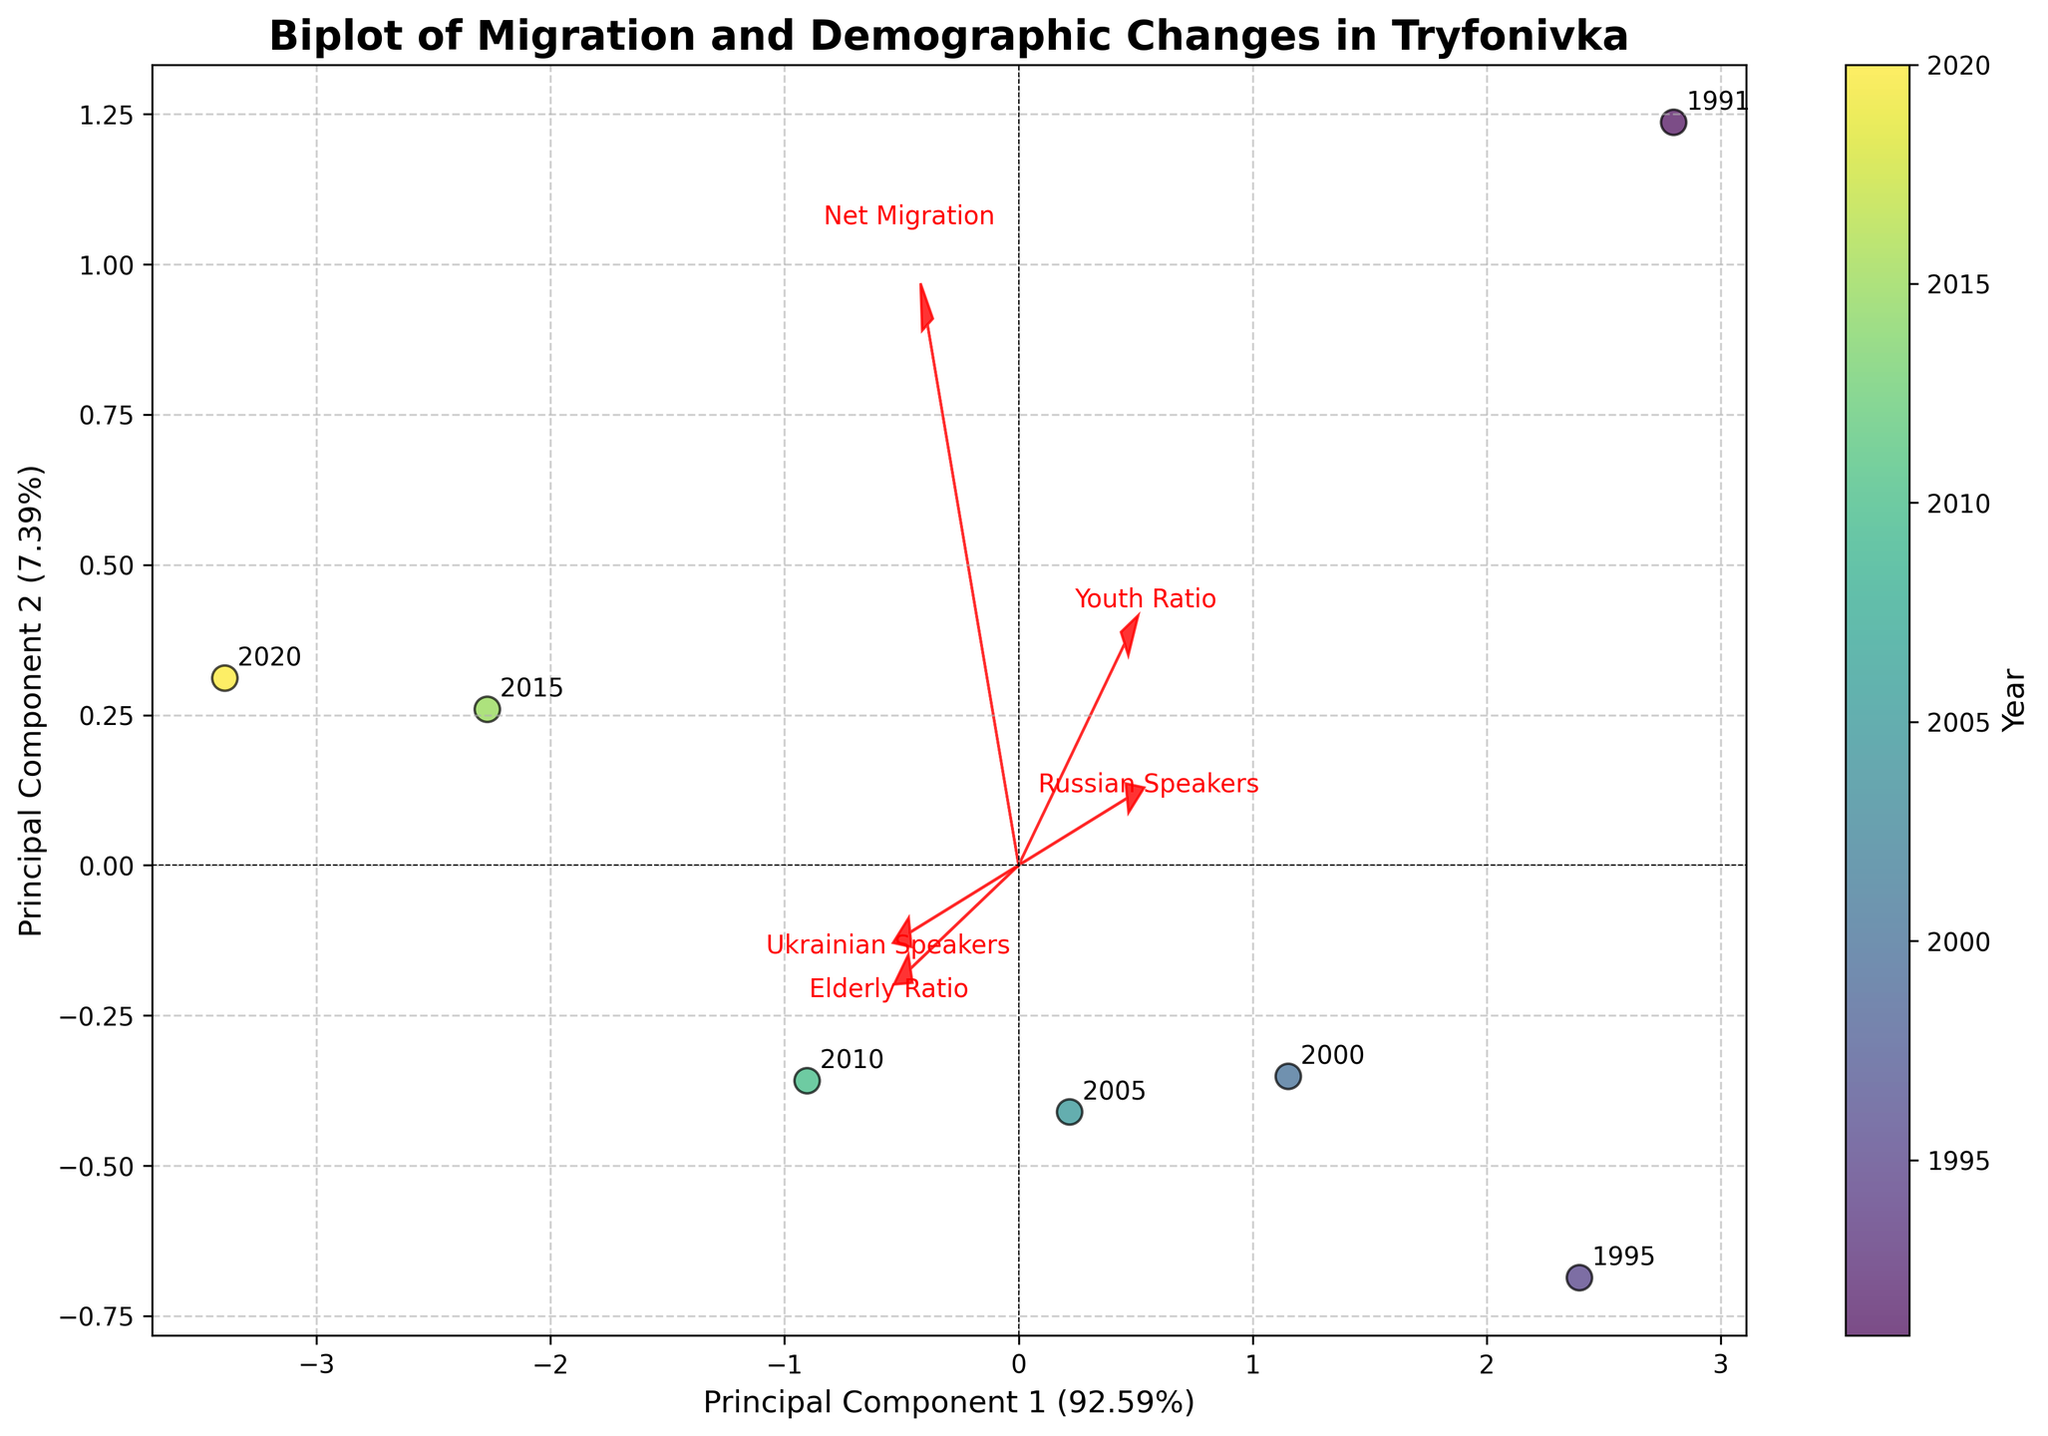How many data points are shown in the biplot? The scatter plot elements in the biplot represent individual data points for each year. We can count the number of annotated years on the plot.
Answer: 7 What is the title of the biplot? The title of a plot is usually located at the top center of the figure. In this case, it states the main focus of the biplot.
Answer: Biplot of Migration and Demographic Changes in Tryfonivka Which year has the highest net migration? Each data point is color-coded by the year and annotated. By looking at the scatter plot, we can identify the year with the highest net migration. The feature vector for 'Net Migration' can help locate the data point in its direction.
Answer: 2020 How does the elderly ratio trend over the years? The feature vector for 'Elderly Ratio' indicates the trend direction. We can observe the annotated years along this vector to identify the trend.
Answer: Increasing Which language's speakers have increased over the years? The directions of the feature vectors for 'Ukrainian Speakers' and 'Russian Speakers' indicate trends. By observing where the data points shift along these vectors, we can deduce which language's speakers increased.
Answer: Ukrainian Speakers Which two years have net migration values closest to zero? By examining the clustering of data points around the origin along the 'Net Migration' vector, and checking the annotated years, we can determine this.
Answer: 1991 and 2010 What does Principal Component 1 mainly represent in this biplot? By observing which feature vectors align closely or have the highest projection on PC1, we can deduce the predominant variables.
Answer: Migration and Language Ratios During which year did the 'Russian Speakers' ratio decline the most? The 'Russian Speakers' feature vector will show direction, and the year closest to the origin after moving opposite to this vector indicates the greatest decline.
Answer: 2020 How are the 'Youth Ratio' and 'Elderly Ratio' related based on the biplot? Observing the angles between the 'Youth Ratio' and 'Elderly Ratio' vectors shows how they relate. If vectors point in opposite directions, it indicates an inverse relationship.
Answer: Inversely Related Which year shows the most balanced youth and elderly ratios? By finding the year closest to the origin on the scatter plot that is not heavily projected onto 'Youth Ratio' or 'Elderly Ratio', we determine the balance.
Answer: 1995 